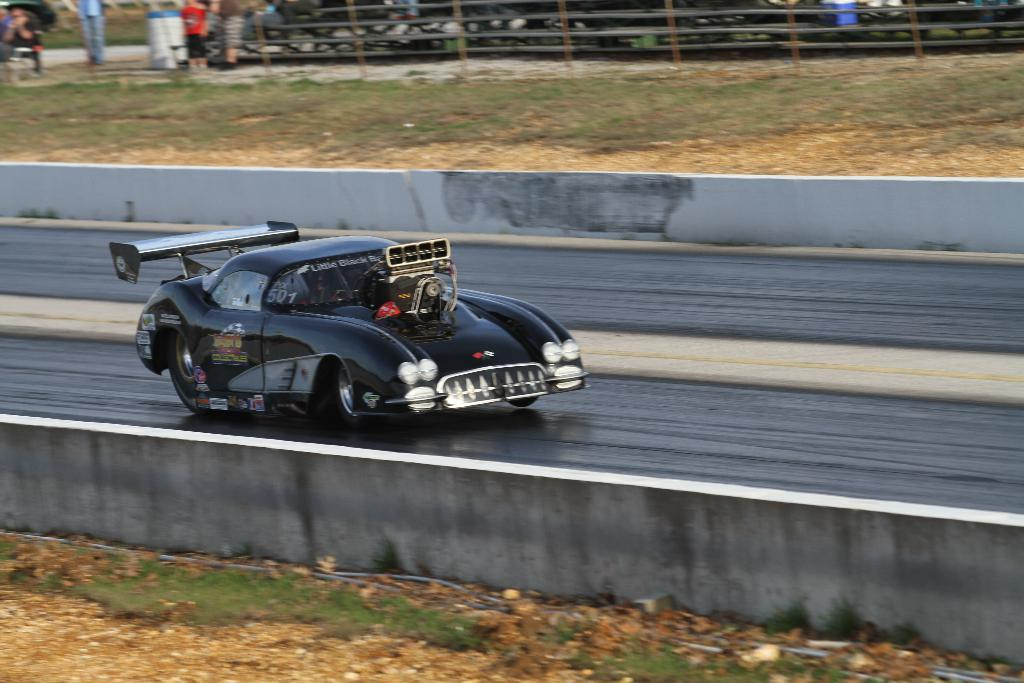What is the main subject of the image? The main subject of the image is a car. What is the car doing in the image? The car is moving on a road in the image. Can you describe the background of the image? In the background, there are people standing, and it appears to depict a racing track. What type of toothbrush can be seen in the image? There is no toothbrush present in the image. What fruit is being consumed by the people in the background? There is no fruit consumption depicted in the image; the people are standing in the background. 